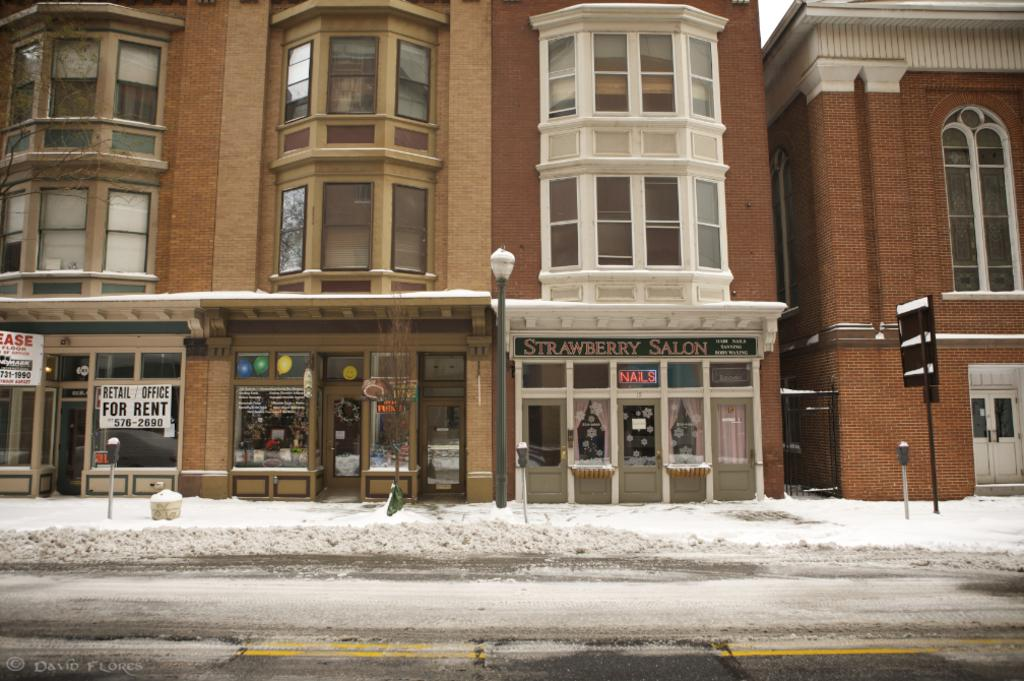What type of structures are located in the center of the image? There are buildings in the center of the image. What type of doors can be seen in the image? There are glass doors in the image. What type of vertical structures are present in the image? There are poles in the image. What type of openings are present in the buildings? There are windows in the image. What type of weather condition is depicted at the bottom of the image? There is snow at the bottom of the image. What type of pathway is visible in the image? There is a walkway in the image. What type of stew is being prepared in the image? There is no stew present in the image. 